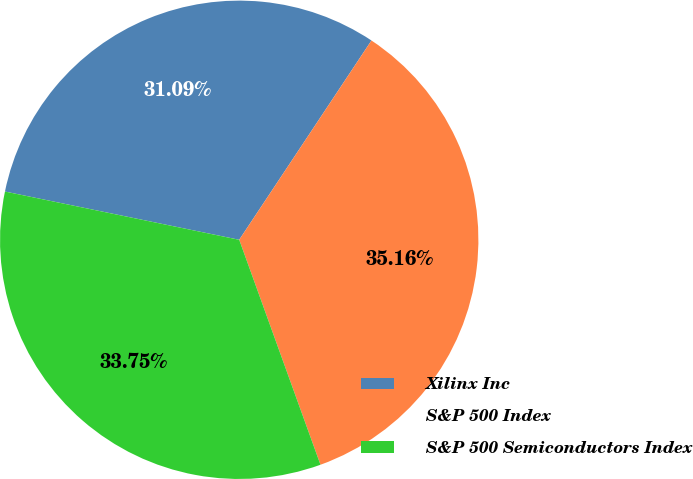Convert chart to OTSL. <chart><loc_0><loc_0><loc_500><loc_500><pie_chart><fcel>Xilinx Inc<fcel>S&P 500 Index<fcel>S&P 500 Semiconductors Index<nl><fcel>31.09%<fcel>35.16%<fcel>33.75%<nl></chart> 